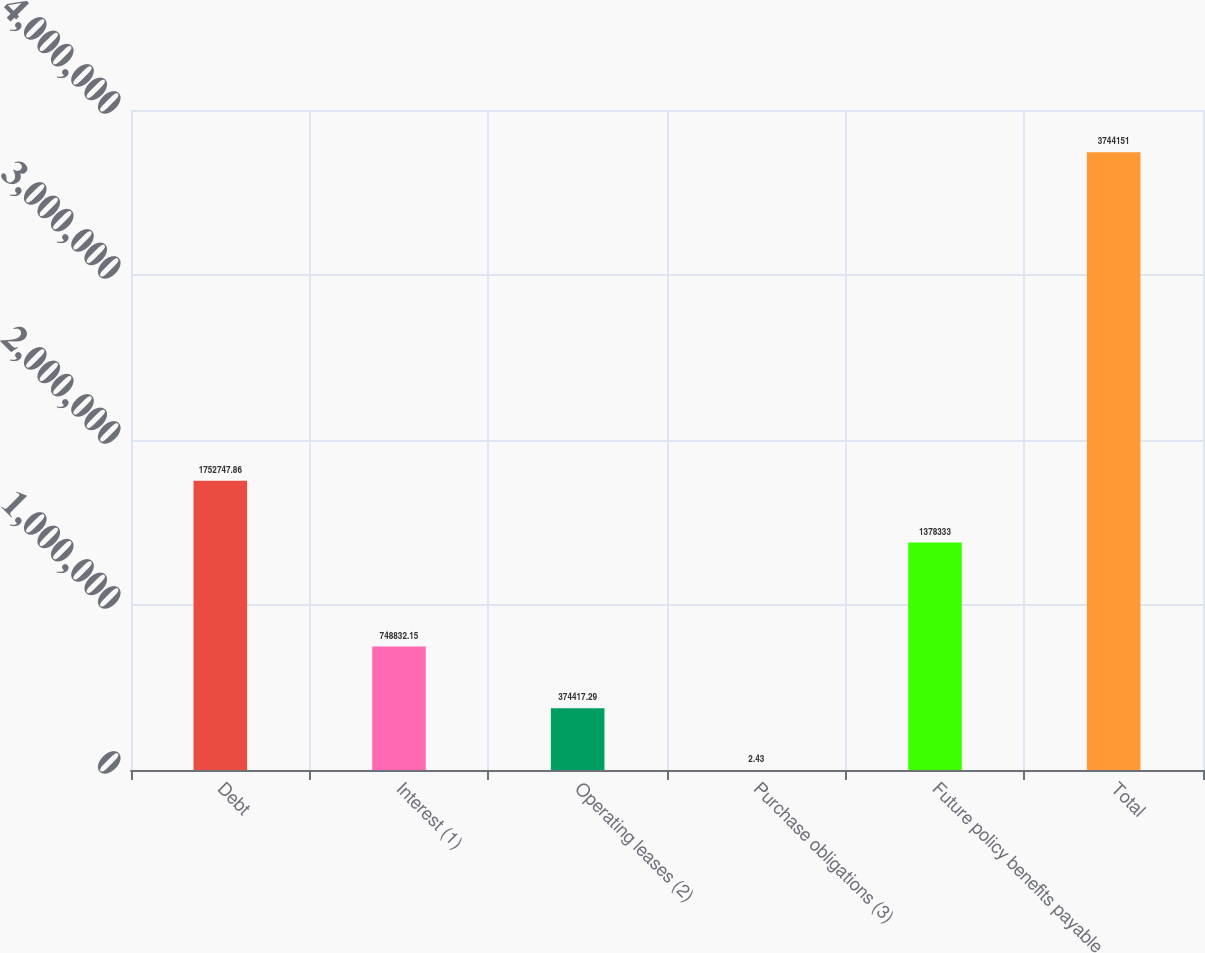<chart> <loc_0><loc_0><loc_500><loc_500><bar_chart><fcel>Debt<fcel>Interest (1)<fcel>Operating leases (2)<fcel>Purchase obligations (3)<fcel>Future policy benefits payable<fcel>Total<nl><fcel>1.75275e+06<fcel>748832<fcel>374417<fcel>2.43<fcel>1.37833e+06<fcel>3.74415e+06<nl></chart> 